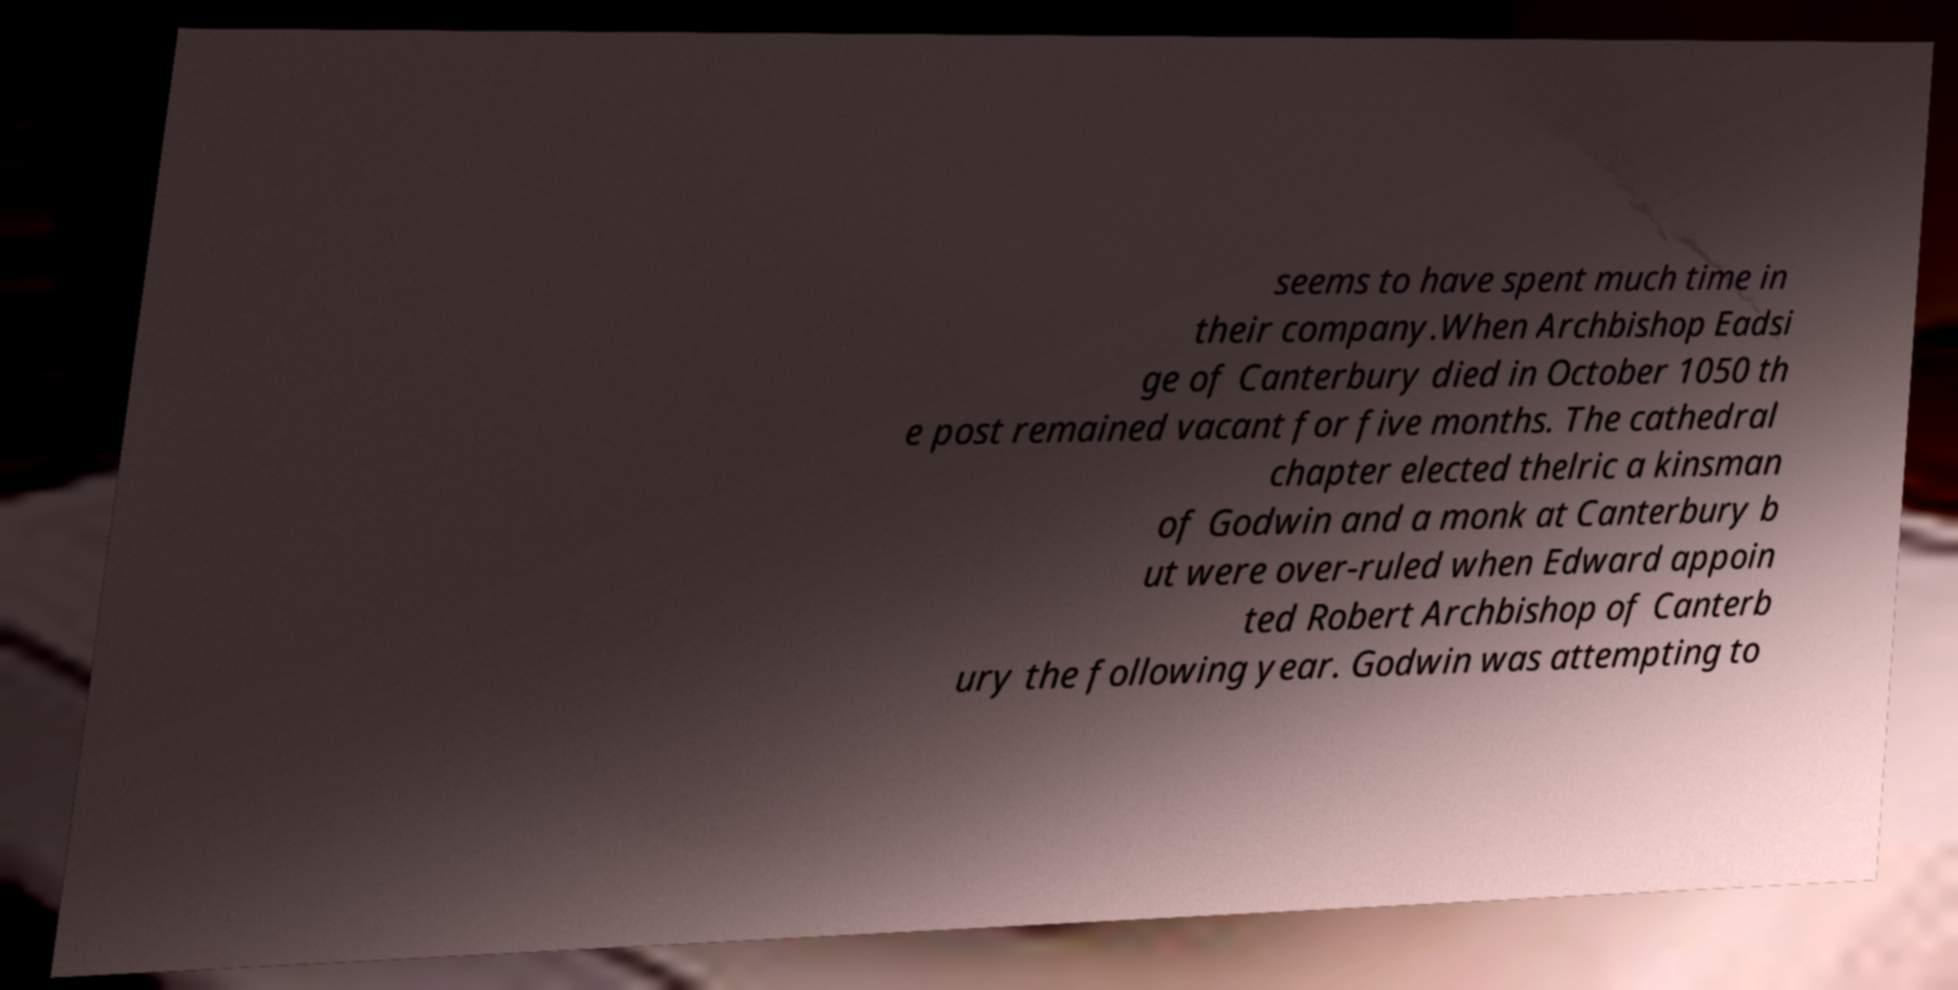Could you assist in decoding the text presented in this image and type it out clearly? seems to have spent much time in their company.When Archbishop Eadsi ge of Canterbury died in October 1050 th e post remained vacant for five months. The cathedral chapter elected thelric a kinsman of Godwin and a monk at Canterbury b ut were over-ruled when Edward appoin ted Robert Archbishop of Canterb ury the following year. Godwin was attempting to 